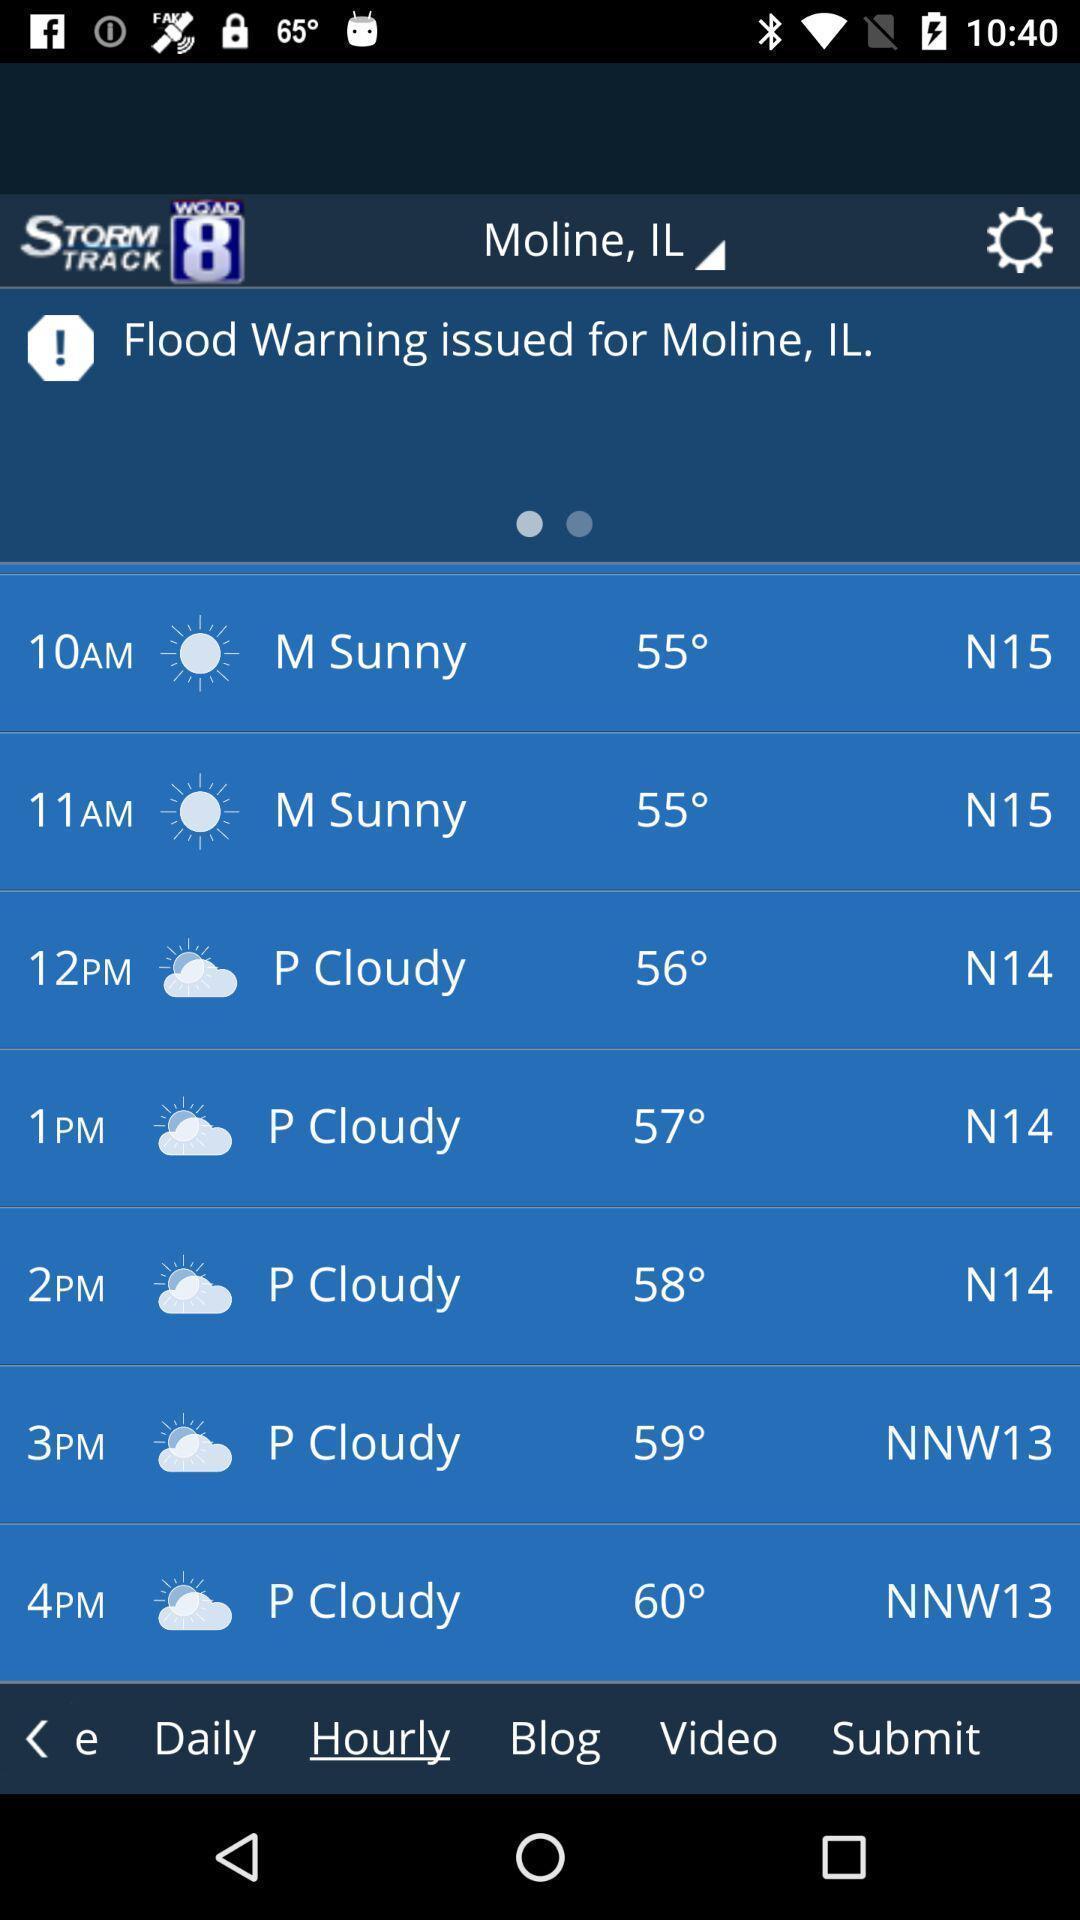Provide a description of this screenshot. Page showing weather forecast by hourly basis. 